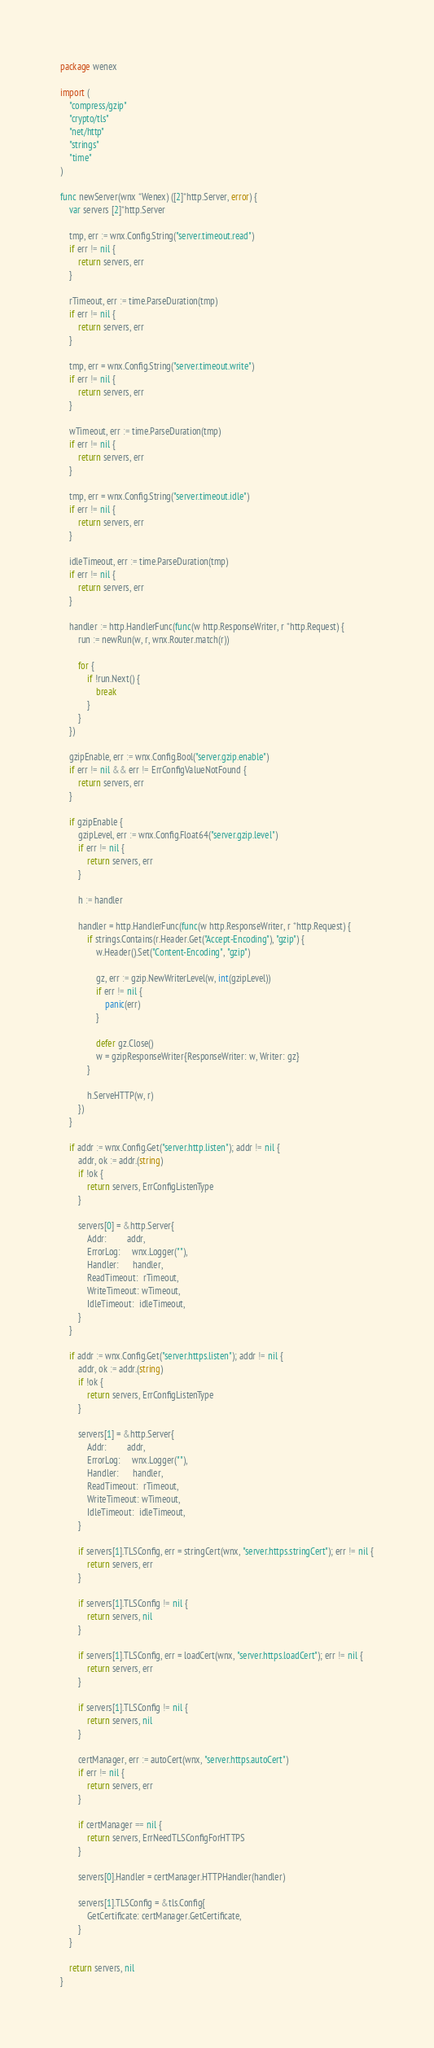<code> <loc_0><loc_0><loc_500><loc_500><_Go_>package wenex

import (
	"compress/gzip"
	"crypto/tls"
	"net/http"
	"strings"
	"time"
)

func newServer(wnx *Wenex) ([2]*http.Server, error) {
	var servers [2]*http.Server

	tmp, err := wnx.Config.String("server.timeout.read")
	if err != nil {
		return servers, err
	}

	rTimeout, err := time.ParseDuration(tmp)
	if err != nil {
		return servers, err
	}

	tmp, err = wnx.Config.String("server.timeout.write")
	if err != nil {
		return servers, err
	}

	wTimeout, err := time.ParseDuration(tmp)
	if err != nil {
		return servers, err
	}

	tmp, err = wnx.Config.String("server.timeout.idle")
	if err != nil {
		return servers, err
	}

	idleTimeout, err := time.ParseDuration(tmp)
	if err != nil {
		return servers, err
	}

	handler := http.HandlerFunc(func(w http.ResponseWriter, r *http.Request) {
		run := newRun(w, r, wnx.Router.match(r))

		for {
			if !run.Next() {
				break
			}
		}
	})

	gzipEnable, err := wnx.Config.Bool("server.gzip.enable")
	if err != nil && err != ErrConfigValueNotFound {
		return servers, err
	}

	if gzipEnable {
		gzipLevel, err := wnx.Config.Float64("server.gzip.level")
		if err != nil {
			return servers, err
		}

		h := handler

		handler = http.HandlerFunc(func(w http.ResponseWriter, r *http.Request) {
			if strings.Contains(r.Header.Get("Accept-Encoding"), "gzip") {
				w.Header().Set("Content-Encoding", "gzip")

				gz, err := gzip.NewWriterLevel(w, int(gzipLevel))
				if err != nil {
					panic(err)
				}

				defer gz.Close()
				w = gzipResponseWriter{ResponseWriter: w, Writer: gz}
			}

			h.ServeHTTP(w, r)
		})
	}

	if addr := wnx.Config.Get("server.http.listen"); addr != nil {
		addr, ok := addr.(string)
		if !ok {
			return servers, ErrConfigListenType
		}

		servers[0] = &http.Server{
			Addr:         addr,
			ErrorLog:     wnx.Logger(""),
			Handler:      handler,
			ReadTimeout:  rTimeout,
			WriteTimeout: wTimeout,
			IdleTimeout:  idleTimeout,
		}
	}

	if addr := wnx.Config.Get("server.https.listen"); addr != nil {
		addr, ok := addr.(string)
		if !ok {
			return servers, ErrConfigListenType
		}

		servers[1] = &http.Server{
			Addr:         addr,
			ErrorLog:     wnx.Logger(""),
			Handler:      handler,
			ReadTimeout:  rTimeout,
			WriteTimeout: wTimeout,
			IdleTimeout:  idleTimeout,
		}

		if servers[1].TLSConfig, err = stringCert(wnx, "server.https.stringCert"); err != nil {
			return servers, err
		}

		if servers[1].TLSConfig != nil {
			return servers, nil
		}

		if servers[1].TLSConfig, err = loadCert(wnx, "server.https.loadCert"); err != nil {
			return servers, err
		}

		if servers[1].TLSConfig != nil {
			return servers, nil
		}

		certManager, err := autoCert(wnx, "server.https.autoCert")
		if err != nil {
			return servers, err
		}

		if certManager == nil {
			return servers, ErrNeedTLSConfigForHTTPS
		}

		servers[0].Handler = certManager.HTTPHandler(handler)

		servers[1].TLSConfig = &tls.Config{
			GetCertificate: certManager.GetCertificate,
		}
	}

	return servers, nil
}
</code> 